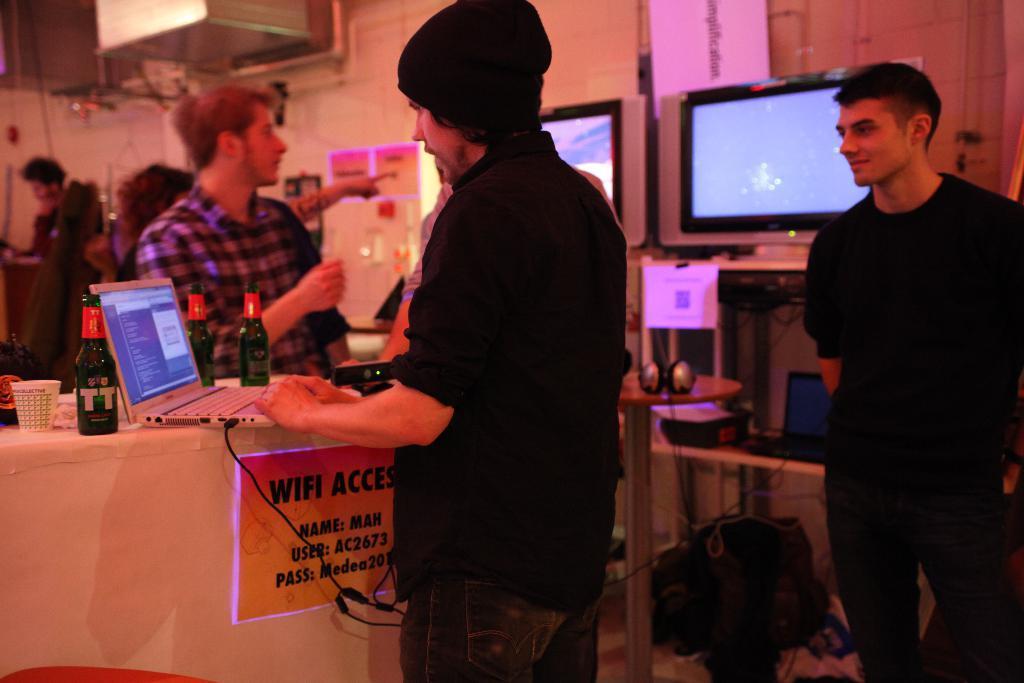Could you give a brief overview of what you see in this image? In this image I can see there are few persons visible in front of the table , on the table I can see a laptop , bottle and glass and a cable card attached to the laptop, on the right side I can see screens and under screens I can see a table , on the table I can see mouse and bags and at the top I can see the wall. 